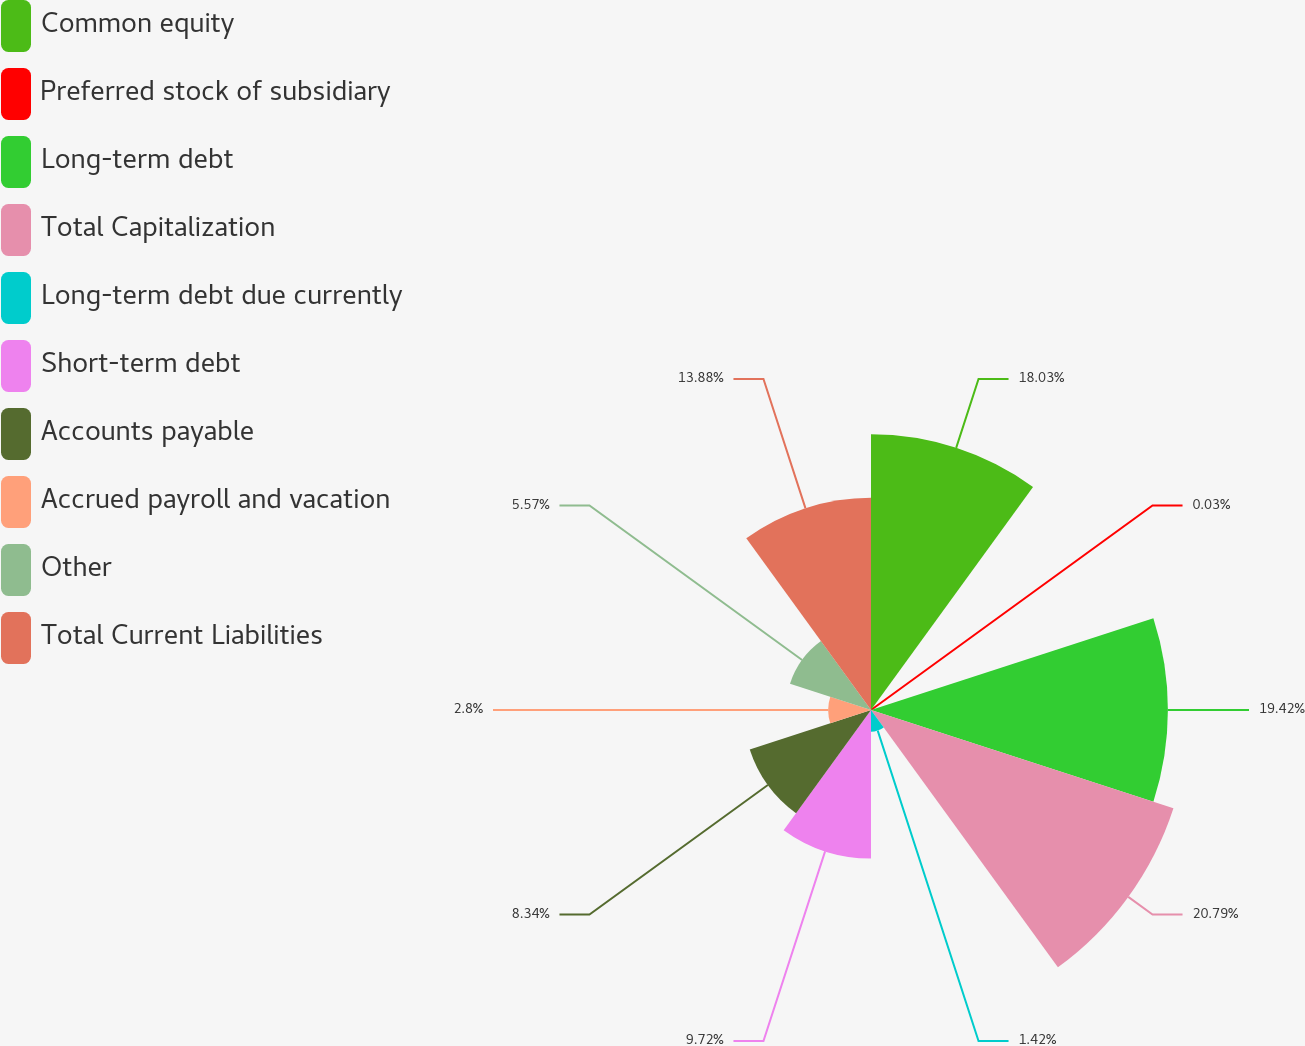Convert chart to OTSL. <chart><loc_0><loc_0><loc_500><loc_500><pie_chart><fcel>Common equity<fcel>Preferred stock of subsidiary<fcel>Long-term debt<fcel>Total Capitalization<fcel>Long-term debt due currently<fcel>Short-term debt<fcel>Accounts payable<fcel>Accrued payroll and vacation<fcel>Other<fcel>Total Current Liabilities<nl><fcel>18.03%<fcel>0.03%<fcel>19.42%<fcel>20.8%<fcel>1.42%<fcel>9.72%<fcel>8.34%<fcel>2.8%<fcel>5.57%<fcel>13.88%<nl></chart> 